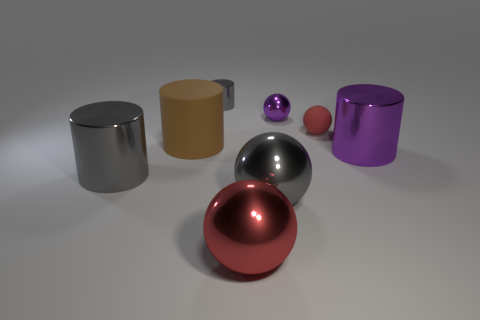Subtract all shiny spheres. How many spheres are left? 1 Subtract all brown balls. How many gray cylinders are left? 2 Subtract all purple cylinders. How many cylinders are left? 3 Subtract 1 balls. How many balls are left? 3 Subtract all cyan cylinders. Subtract all blue blocks. How many cylinders are left? 4 Add 2 large gray metal cylinders. How many objects exist? 10 Subtract 2 red balls. How many objects are left? 6 Subtract all purple things. Subtract all large red spheres. How many objects are left? 5 Add 5 red spheres. How many red spheres are left? 7 Add 3 small red matte things. How many small red matte things exist? 4 